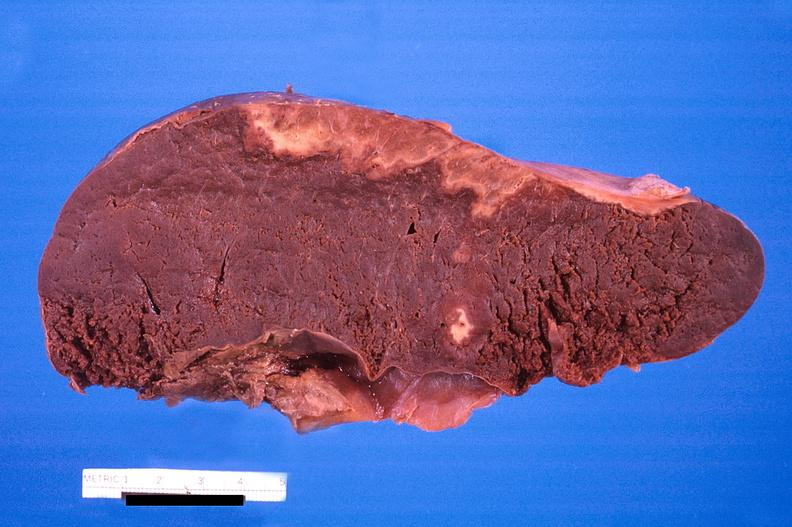does typical tuberculous exudate show spleen, infarcts, disseminated intravascular coagulation?
Answer the question using a single word or phrase. No 